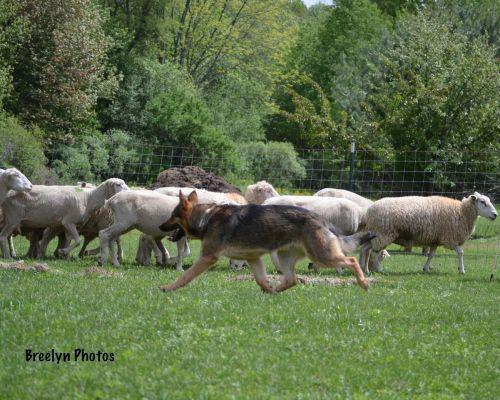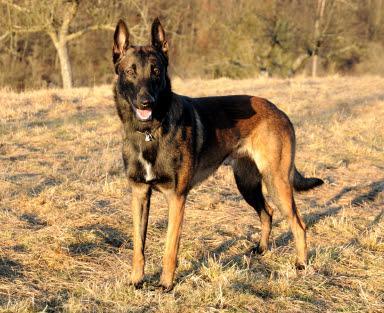The first image is the image on the left, the second image is the image on the right. Given the left and right images, does the statement "All images show a dog with sheep." hold true? Answer yes or no. No. The first image is the image on the left, the second image is the image on the right. For the images shown, is this caption "In one image, no livestock are present but at least one dog is visible." true? Answer yes or no. Yes. 